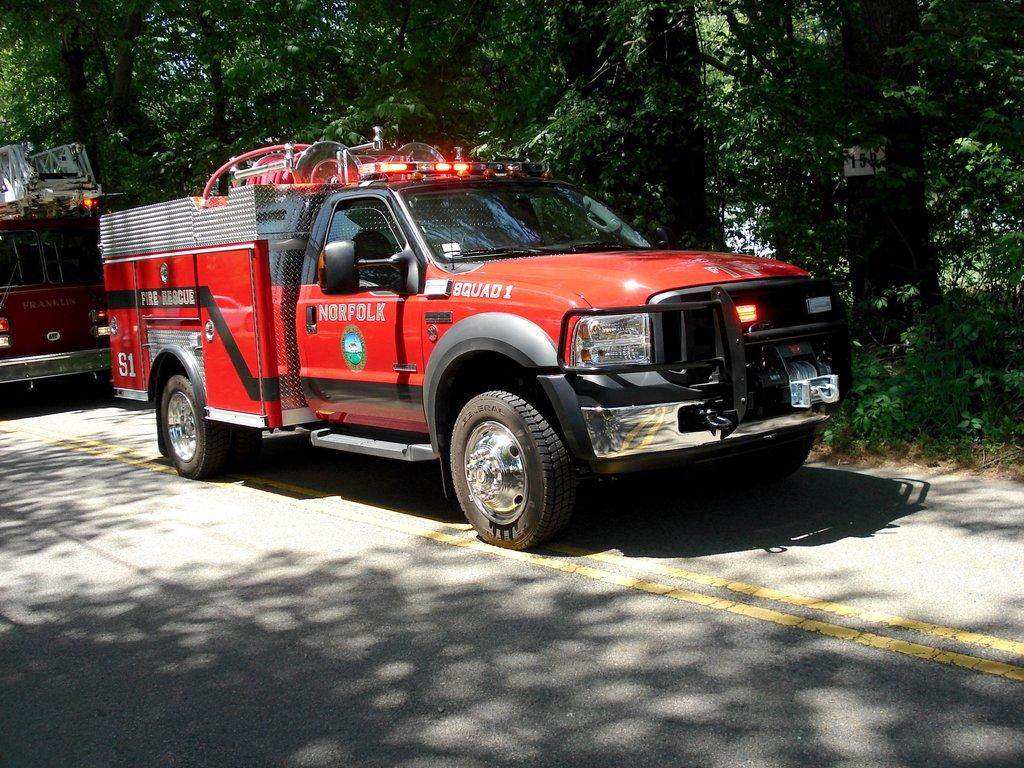How many vehicles can be seen on the road in the image? There are two vehicles on the road in the image. Which direction is one of the vehicles facing? One vehicle is facing towards the right side. What can be seen in the background of the image? There are many trees in the background. Can you hear a voice arguing in the image? There is no audio or indication of a fight or argument in the image; it only contains a visual representation of two vehicles on the road and trees in the background. 